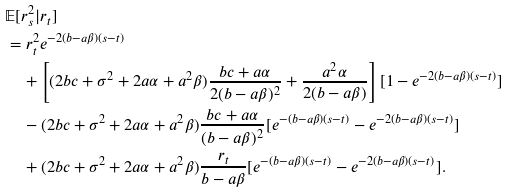<formula> <loc_0><loc_0><loc_500><loc_500>& \mathbb { E } [ r _ { s } ^ { 2 } | r _ { t } ] \\ & = r _ { t } ^ { 2 } e ^ { - 2 ( b - a \beta ) ( s - t ) } \\ & \quad + \left [ ( 2 b c + \sigma ^ { 2 } + 2 a \alpha + a ^ { 2 } \beta ) \frac { b c + a \alpha } { 2 ( b - a \beta ) ^ { 2 } } + \frac { a ^ { 2 } \alpha } { 2 ( b - a \beta ) } \right ] [ 1 - e ^ { - 2 ( b - a \beta ) ( s - t ) } ] \\ & \quad - ( 2 b c + \sigma ^ { 2 } + 2 a \alpha + a ^ { 2 } \beta ) \frac { b c + a \alpha } { ( b - a \beta ) ^ { 2 } } [ e ^ { - ( b - a \beta ) ( s - t ) } - e ^ { - 2 ( b - a \beta ) ( s - t ) } ] \\ & \quad + ( 2 b c + \sigma ^ { 2 } + 2 a \alpha + a ^ { 2 } \beta ) \frac { r _ { t } } { b - a \beta } [ e ^ { - ( b - a \beta ) ( s - t ) } - e ^ { - 2 ( b - a \beta ) ( s - t ) } ] .</formula> 